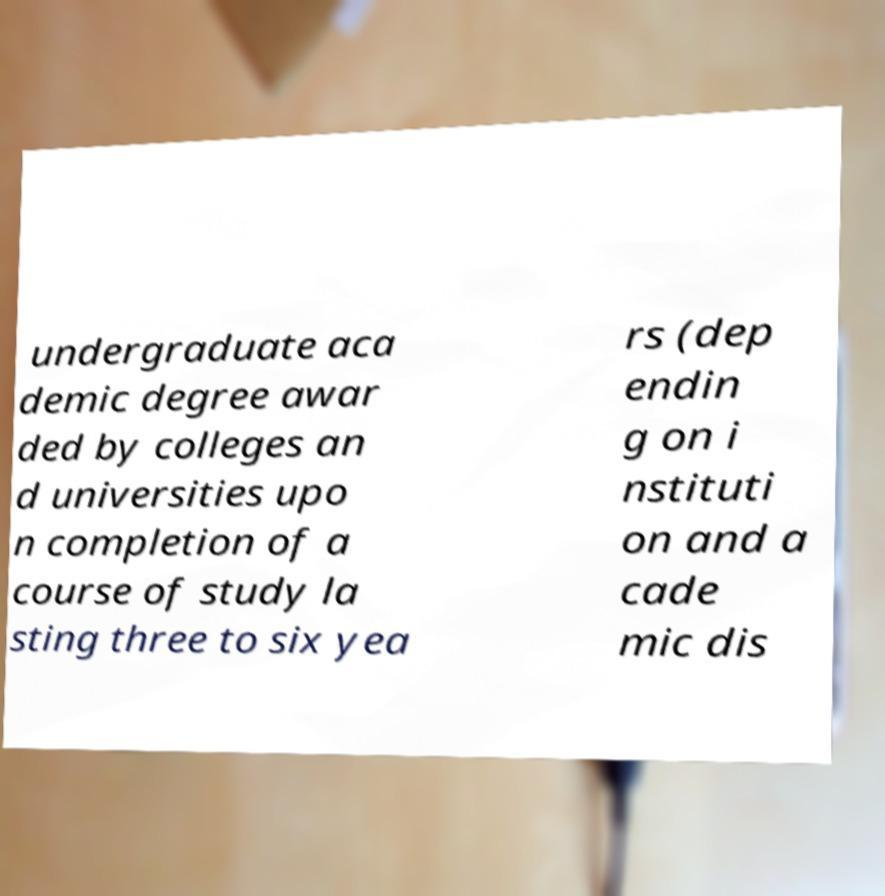Please read and relay the text visible in this image. What does it say? undergraduate aca demic degree awar ded by colleges an d universities upo n completion of a course of study la sting three to six yea rs (dep endin g on i nstituti on and a cade mic dis 